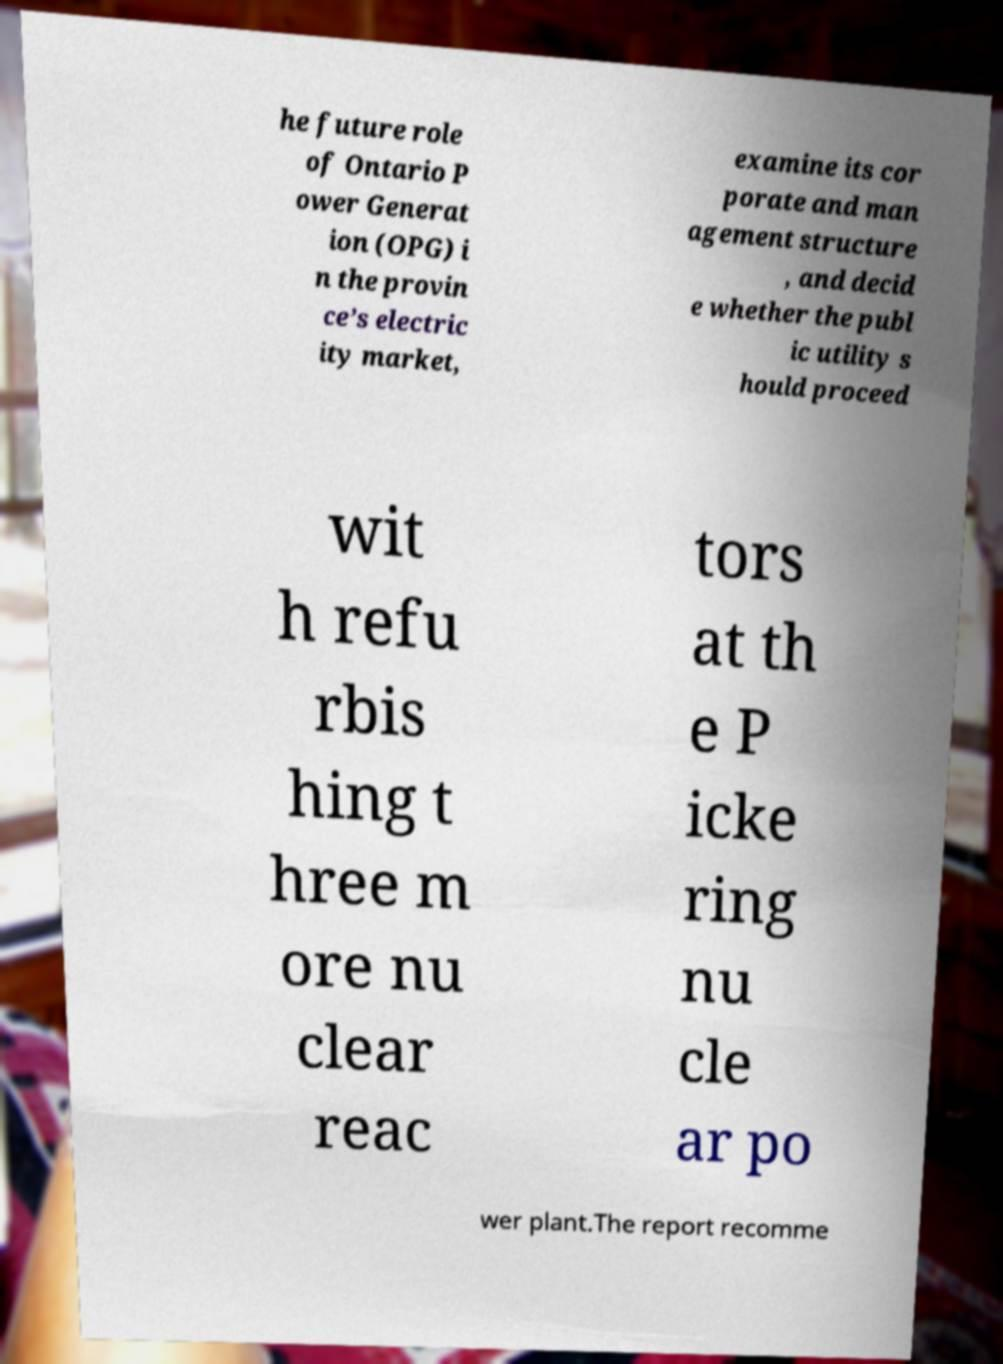For documentation purposes, I need the text within this image transcribed. Could you provide that? he future role of Ontario P ower Generat ion (OPG) i n the provin ce’s electric ity market, examine its cor porate and man agement structure , and decid e whether the publ ic utility s hould proceed wit h refu rbis hing t hree m ore nu clear reac tors at th e P icke ring nu cle ar po wer plant.The report recomme 